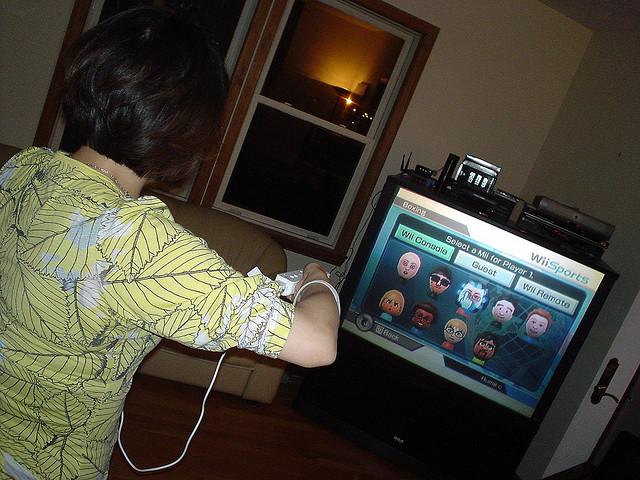What is the overlapping design on the woman's shirt?
Short answer required. Leaves. What color is the women's shirt?
Keep it brief. Yellow. What is the woman playing?
Concise answer only. Wii. What does the screen say?
Short answer required. Wii sports. 